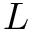Convert formula to latex. <formula><loc_0><loc_0><loc_500><loc_500>L</formula> 